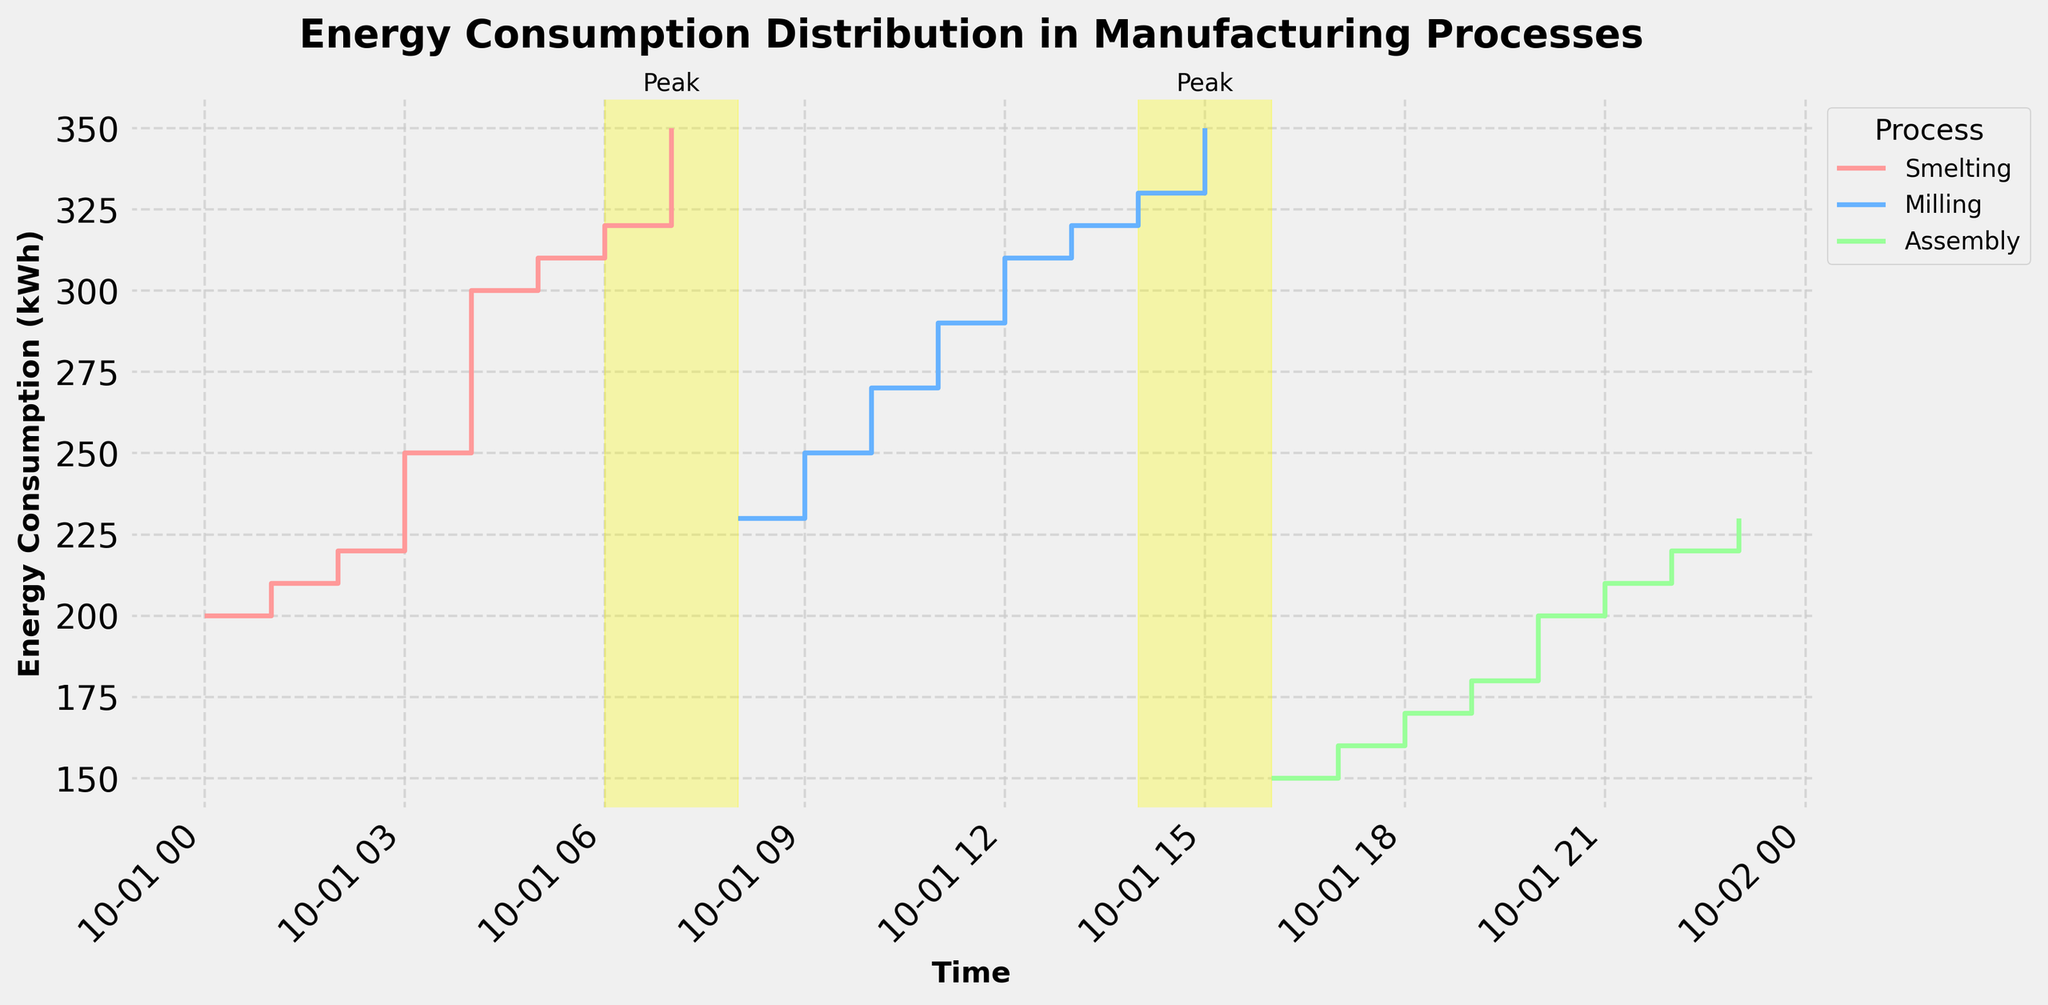What is the title of the figure? The title of the figure is located at the top of the plot and is designed to provide a clear and concise description of the data being presented.
Answer: Energy Consumption Distribution in Manufacturing Processes What are the peak periods highlighted in the figure? The peak periods are visually highlighted with a yellow span on the plot. Looking at the time intervals where this occurs, it can be seen between the ranges.
Answer: 06:00-08:00 and 14:00-16:00 Which manufacturing process has the highest energy consumption at 15:00? At 15:00, the plot shows stair steps for different processes, allowing us to identify the corresponding energy consumption levels at that specific time. By comparing these levels, the Manufacturing processing having the highest energy consumption at 15:00 can be identified.
Answer: Milling What is the total energy consumption for the Assembly process? To find the total energy consumption for the Assembly process, navigate through the plot where the steps represent the energy consumption at each hour for Assembly and add them together.
Answer: 150 + 160 + 170 + 180 + 200 + 210 + 220 + 230 = 1520 kWh Compare the energy consumption at 10:00 and 22:00 for their respective processes. Which one is higher? Looking at the plot at 10:00 and 22:00, each step represents the energy consumption value at that hour for the specific process. Compare these values directly.
Answer: 270 kWh (Milling) vs 220 kWh (Assembly); 10:00 is higher During which hour does the Smelting process reach its peak energy consumption? For the Smelting process, each step on the plot corresponds to an hourly energy consumption value. Identify the highest value and note the corresponding hour.
Answer: 07:00 What trend can you observe in the energy consumption of the Milling process from 08:00 to 15:00? Observe the steps for the Milling process from 08:00 to 15:00. Note the direction (increase/decrease) and steepness of the steps to determine the overall trend over this time period.
Answer: Increasing trend How does the energy consumption in the peak period 14:00-16:00 compare for Milling and Assembly processes? During 14:00-16:00, observe the steps for Milling and Assembly. Compare their energy consumption values at both start and end of this period to determine any differences.
Answer: Milling is higher than Assembly Which process consistently consumes the least energy across the entire day? By visually comparing the steps across all processes throughout the entire day on the plot, identify the process with the consistently lowest values.
Answer: Assembly 